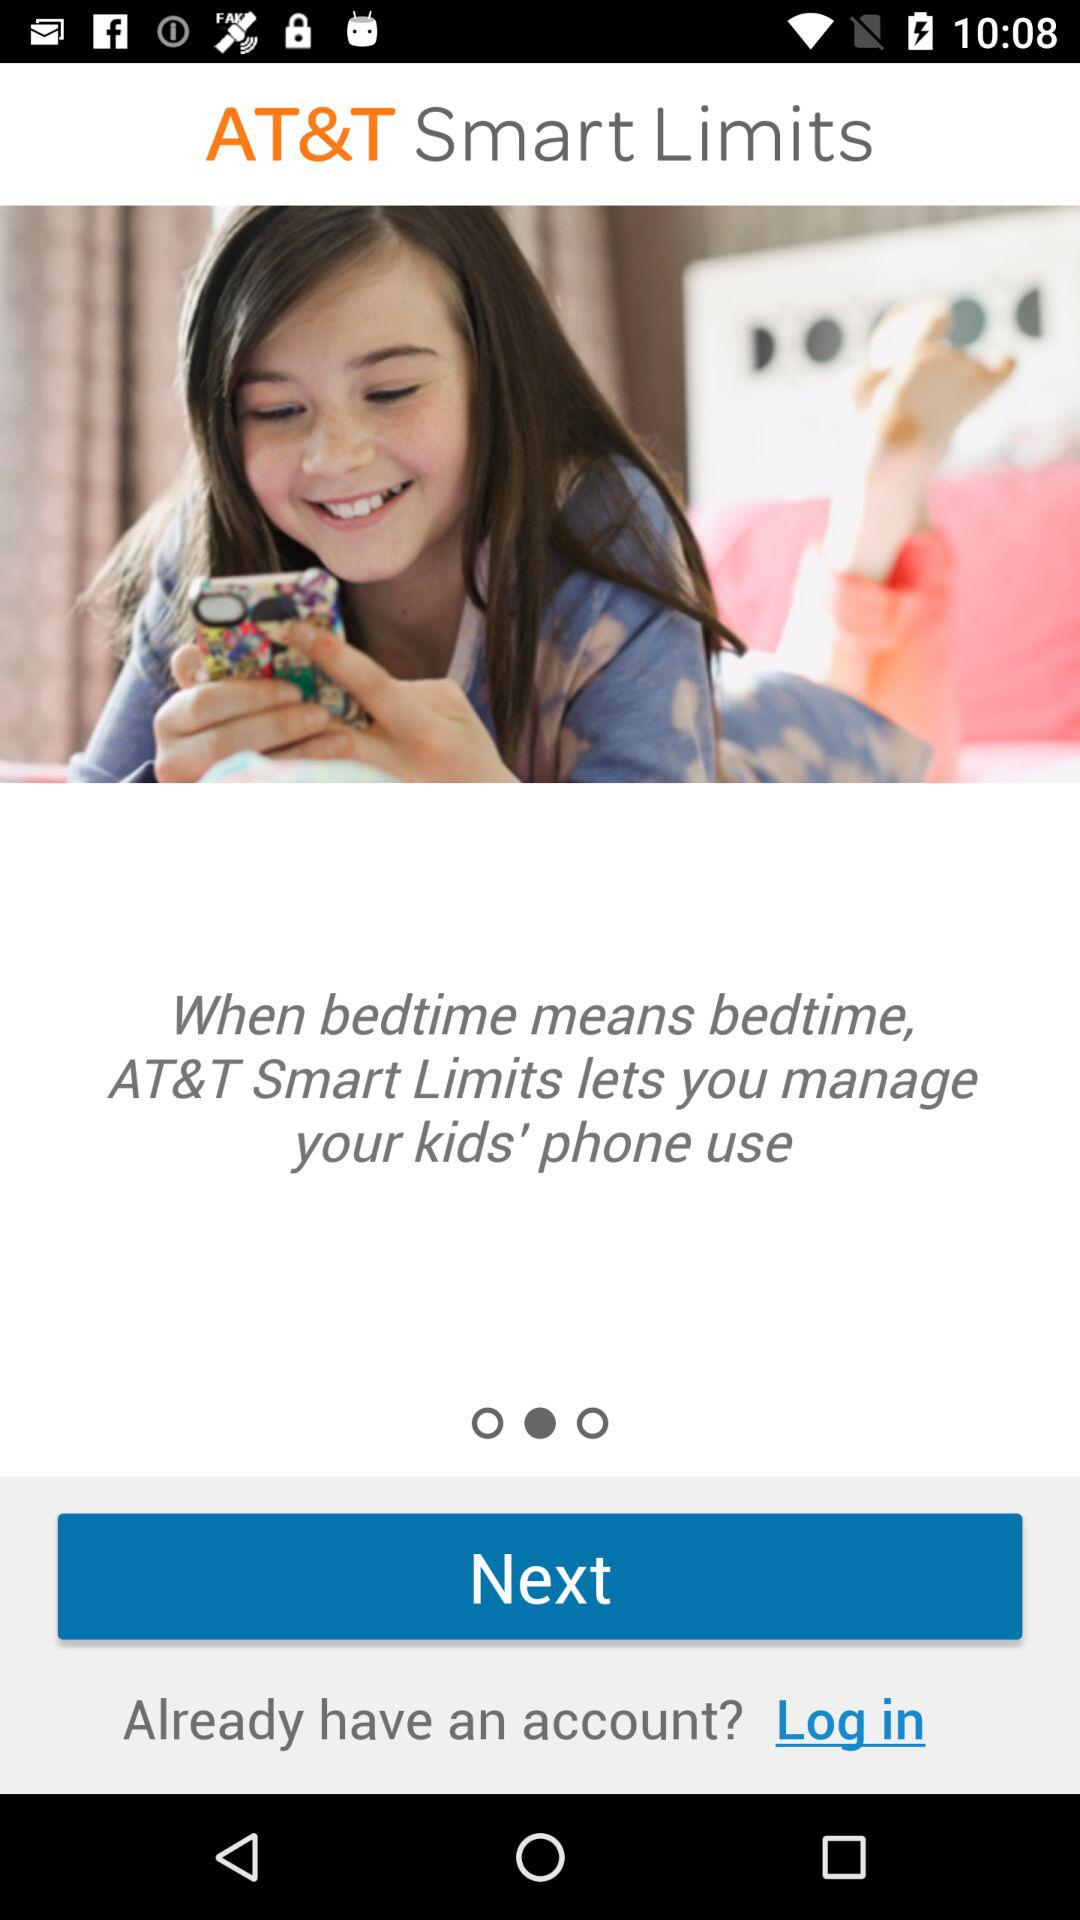What is the application name? The application name is "AT&T Smart Limits". 